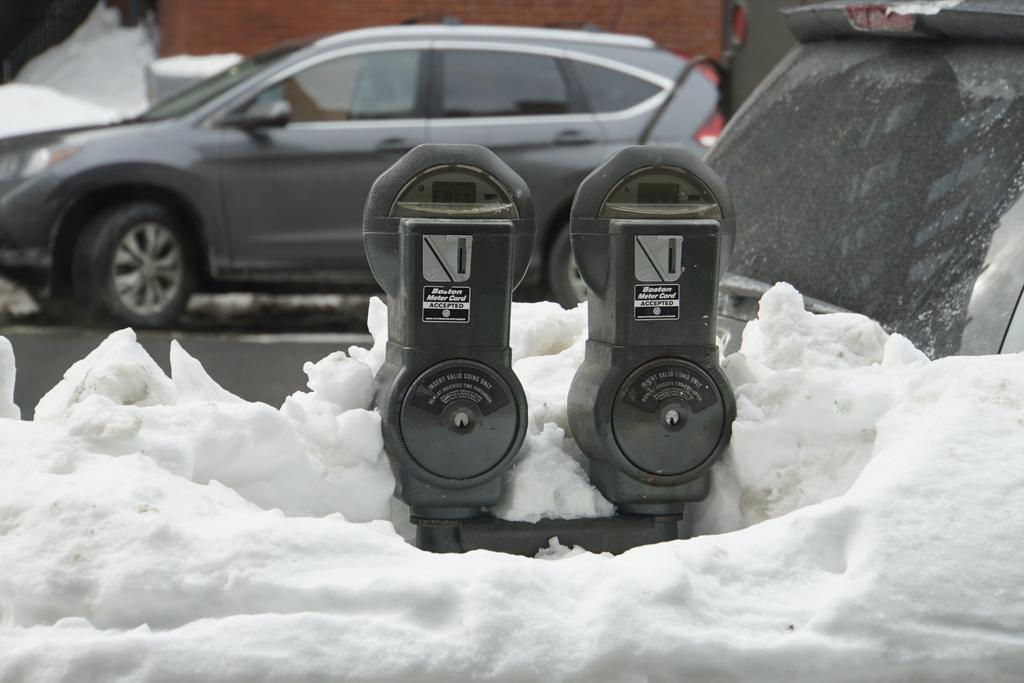<image>
Summarize the visual content of the image. A picture of two parking meters that read "insert coins here." 